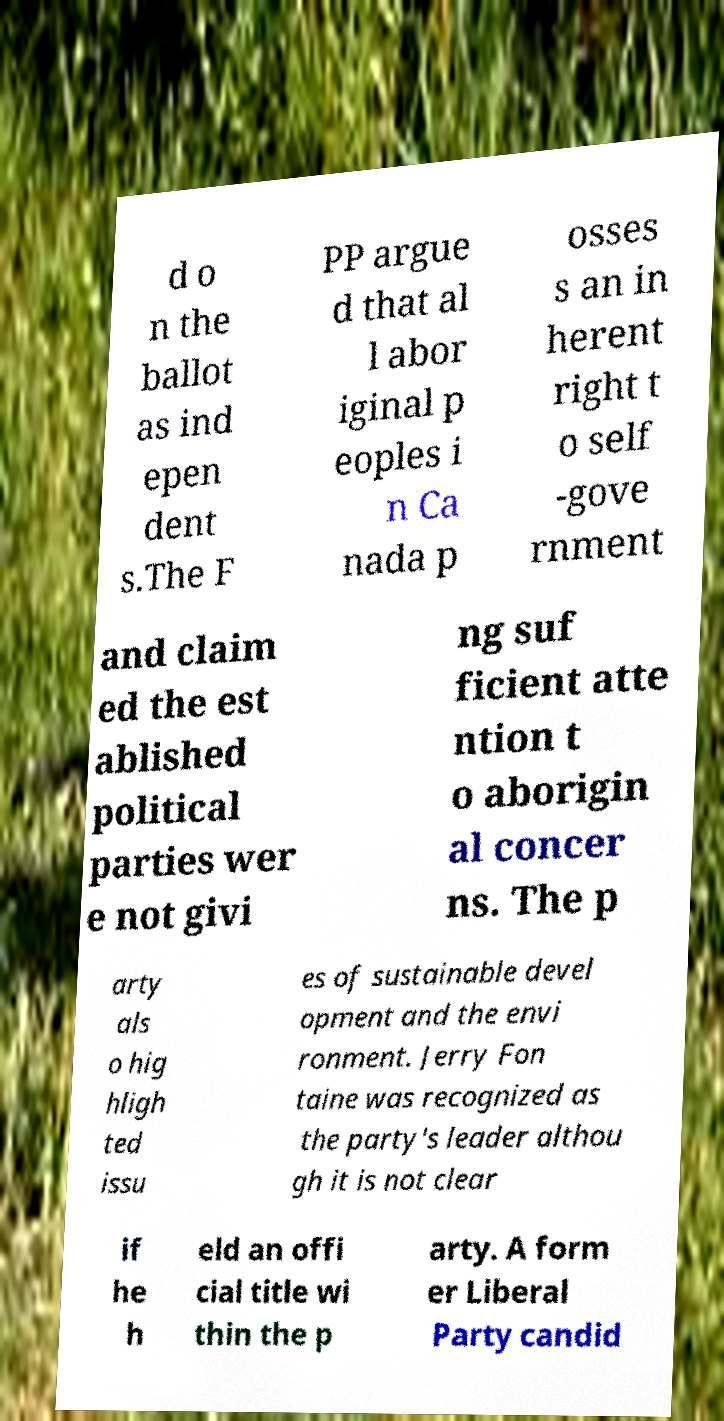Could you extract and type out the text from this image? d o n the ballot as ind epen dent s.The F PP argue d that al l abor iginal p eoples i n Ca nada p osses s an in herent right t o self -gove rnment and claim ed the est ablished political parties wer e not givi ng suf ficient atte ntion t o aborigin al concer ns. The p arty als o hig hligh ted issu es of sustainable devel opment and the envi ronment. Jerry Fon taine was recognized as the party's leader althou gh it is not clear if he h eld an offi cial title wi thin the p arty. A form er Liberal Party candid 